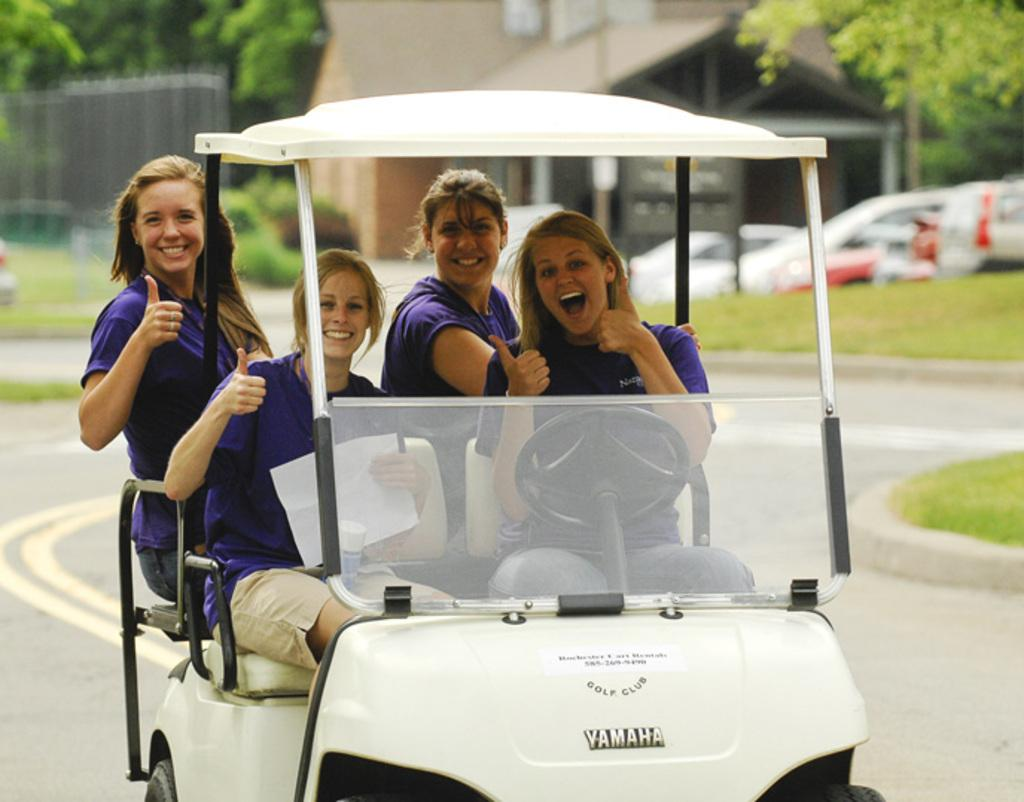How many people are in the image? There are four women in the image. What are the women doing in the image? The women are riding an electric vehicle. Where is the electric vehicle located? The electric vehicle is on a road. Are there any men playing bikes in the image? There are no men or bikes present in the image; it features four women riding an electric vehicle. 